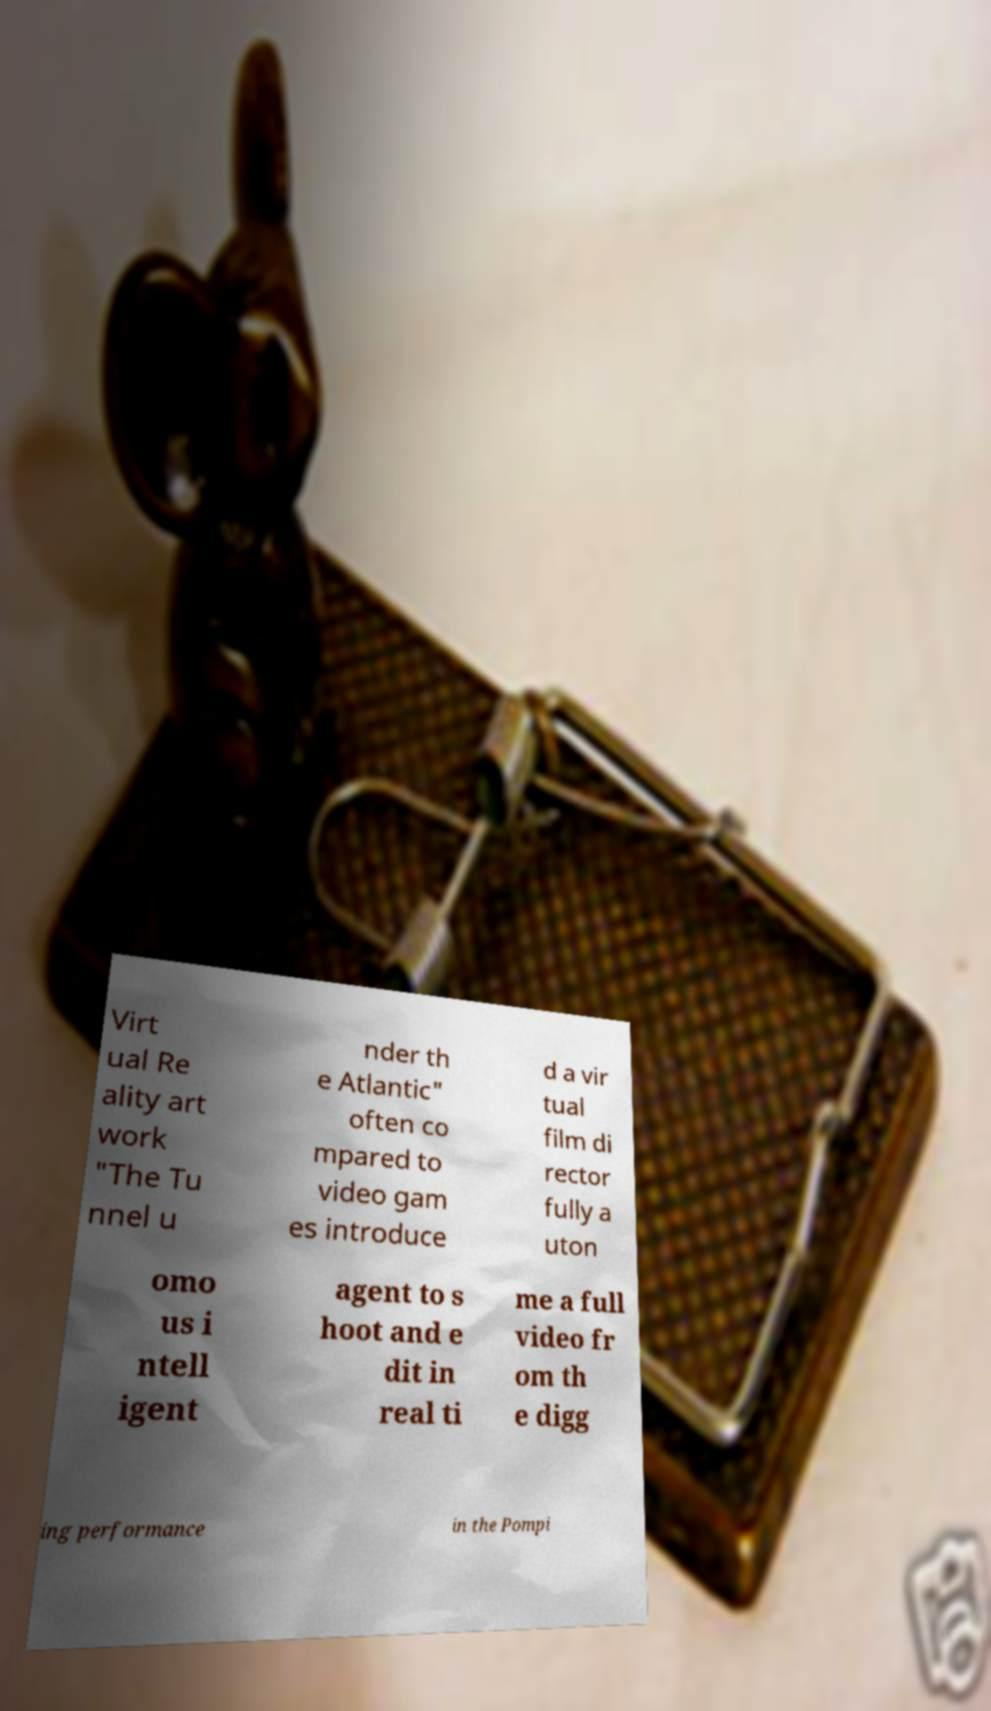For documentation purposes, I need the text within this image transcribed. Could you provide that? Virt ual Re ality art work "The Tu nnel u nder th e Atlantic" often co mpared to video gam es introduce d a vir tual film di rector fully a uton omo us i ntell igent agent to s hoot and e dit in real ti me a full video fr om th e digg ing performance in the Pompi 